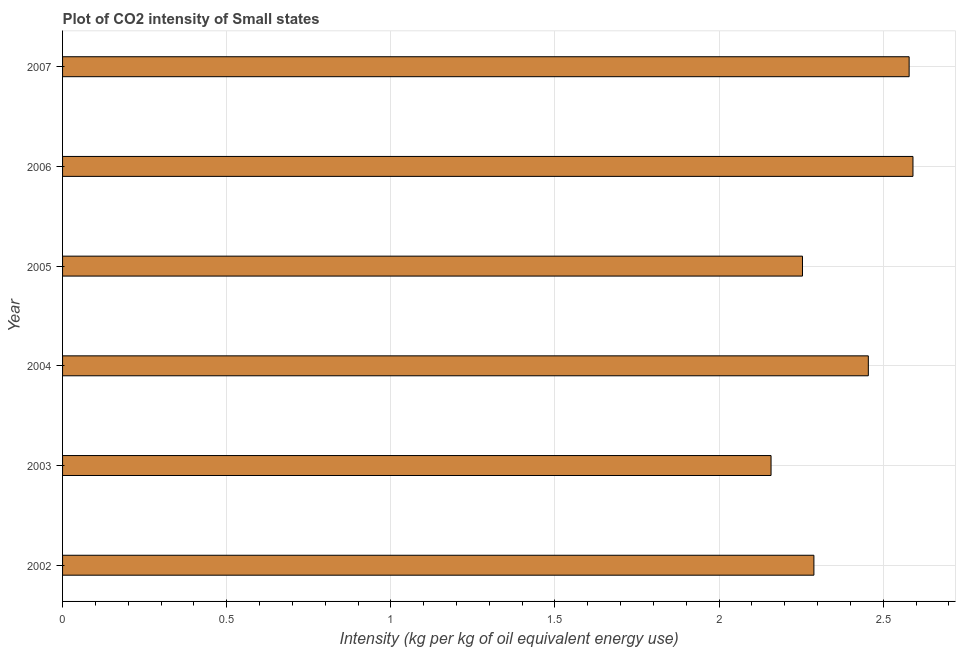What is the title of the graph?
Your answer should be very brief. Plot of CO2 intensity of Small states. What is the label or title of the X-axis?
Provide a short and direct response. Intensity (kg per kg of oil equivalent energy use). What is the label or title of the Y-axis?
Your answer should be compact. Year. What is the co2 intensity in 2007?
Provide a short and direct response. 2.58. Across all years, what is the maximum co2 intensity?
Offer a terse response. 2.59. Across all years, what is the minimum co2 intensity?
Ensure brevity in your answer.  2.16. In which year was the co2 intensity maximum?
Keep it short and to the point. 2006. In which year was the co2 intensity minimum?
Make the answer very short. 2003. What is the sum of the co2 intensity?
Make the answer very short. 14.33. What is the difference between the co2 intensity in 2003 and 2005?
Your answer should be very brief. -0.1. What is the average co2 intensity per year?
Provide a succinct answer. 2.39. What is the median co2 intensity?
Ensure brevity in your answer.  2.37. Do a majority of the years between 2003 and 2007 (inclusive) have co2 intensity greater than 0.6 kg?
Make the answer very short. Yes. What is the ratio of the co2 intensity in 2002 to that in 2004?
Your answer should be compact. 0.93. What is the difference between the highest and the second highest co2 intensity?
Provide a short and direct response. 0.01. Is the sum of the co2 intensity in 2006 and 2007 greater than the maximum co2 intensity across all years?
Offer a terse response. Yes. What is the difference between the highest and the lowest co2 intensity?
Offer a terse response. 0.43. What is the difference between two consecutive major ticks on the X-axis?
Provide a succinct answer. 0.5. What is the Intensity (kg per kg of oil equivalent energy use) in 2002?
Your answer should be compact. 2.29. What is the Intensity (kg per kg of oil equivalent energy use) in 2003?
Ensure brevity in your answer.  2.16. What is the Intensity (kg per kg of oil equivalent energy use) in 2004?
Your answer should be very brief. 2.45. What is the Intensity (kg per kg of oil equivalent energy use) in 2005?
Give a very brief answer. 2.25. What is the Intensity (kg per kg of oil equivalent energy use) in 2006?
Provide a succinct answer. 2.59. What is the Intensity (kg per kg of oil equivalent energy use) in 2007?
Offer a terse response. 2.58. What is the difference between the Intensity (kg per kg of oil equivalent energy use) in 2002 and 2003?
Provide a succinct answer. 0.13. What is the difference between the Intensity (kg per kg of oil equivalent energy use) in 2002 and 2004?
Your answer should be compact. -0.17. What is the difference between the Intensity (kg per kg of oil equivalent energy use) in 2002 and 2005?
Your answer should be very brief. 0.03. What is the difference between the Intensity (kg per kg of oil equivalent energy use) in 2002 and 2006?
Make the answer very short. -0.3. What is the difference between the Intensity (kg per kg of oil equivalent energy use) in 2002 and 2007?
Provide a succinct answer. -0.29. What is the difference between the Intensity (kg per kg of oil equivalent energy use) in 2003 and 2004?
Your answer should be very brief. -0.3. What is the difference between the Intensity (kg per kg of oil equivalent energy use) in 2003 and 2005?
Your response must be concise. -0.1. What is the difference between the Intensity (kg per kg of oil equivalent energy use) in 2003 and 2006?
Provide a short and direct response. -0.43. What is the difference between the Intensity (kg per kg of oil equivalent energy use) in 2003 and 2007?
Your answer should be very brief. -0.42. What is the difference between the Intensity (kg per kg of oil equivalent energy use) in 2004 and 2005?
Provide a succinct answer. 0.2. What is the difference between the Intensity (kg per kg of oil equivalent energy use) in 2004 and 2006?
Your response must be concise. -0.14. What is the difference between the Intensity (kg per kg of oil equivalent energy use) in 2004 and 2007?
Offer a very short reply. -0.12. What is the difference between the Intensity (kg per kg of oil equivalent energy use) in 2005 and 2006?
Provide a succinct answer. -0.34. What is the difference between the Intensity (kg per kg of oil equivalent energy use) in 2005 and 2007?
Ensure brevity in your answer.  -0.32. What is the difference between the Intensity (kg per kg of oil equivalent energy use) in 2006 and 2007?
Offer a terse response. 0.01. What is the ratio of the Intensity (kg per kg of oil equivalent energy use) in 2002 to that in 2003?
Ensure brevity in your answer.  1.06. What is the ratio of the Intensity (kg per kg of oil equivalent energy use) in 2002 to that in 2004?
Ensure brevity in your answer.  0.93. What is the ratio of the Intensity (kg per kg of oil equivalent energy use) in 2002 to that in 2006?
Keep it short and to the point. 0.88. What is the ratio of the Intensity (kg per kg of oil equivalent energy use) in 2002 to that in 2007?
Your response must be concise. 0.89. What is the ratio of the Intensity (kg per kg of oil equivalent energy use) in 2003 to that in 2004?
Your response must be concise. 0.88. What is the ratio of the Intensity (kg per kg of oil equivalent energy use) in 2003 to that in 2005?
Keep it short and to the point. 0.96. What is the ratio of the Intensity (kg per kg of oil equivalent energy use) in 2003 to that in 2006?
Your response must be concise. 0.83. What is the ratio of the Intensity (kg per kg of oil equivalent energy use) in 2003 to that in 2007?
Keep it short and to the point. 0.84. What is the ratio of the Intensity (kg per kg of oil equivalent energy use) in 2004 to that in 2005?
Make the answer very short. 1.09. What is the ratio of the Intensity (kg per kg of oil equivalent energy use) in 2004 to that in 2006?
Make the answer very short. 0.95. What is the ratio of the Intensity (kg per kg of oil equivalent energy use) in 2005 to that in 2006?
Keep it short and to the point. 0.87. What is the ratio of the Intensity (kg per kg of oil equivalent energy use) in 2005 to that in 2007?
Offer a very short reply. 0.87. What is the ratio of the Intensity (kg per kg of oil equivalent energy use) in 2006 to that in 2007?
Keep it short and to the point. 1. 